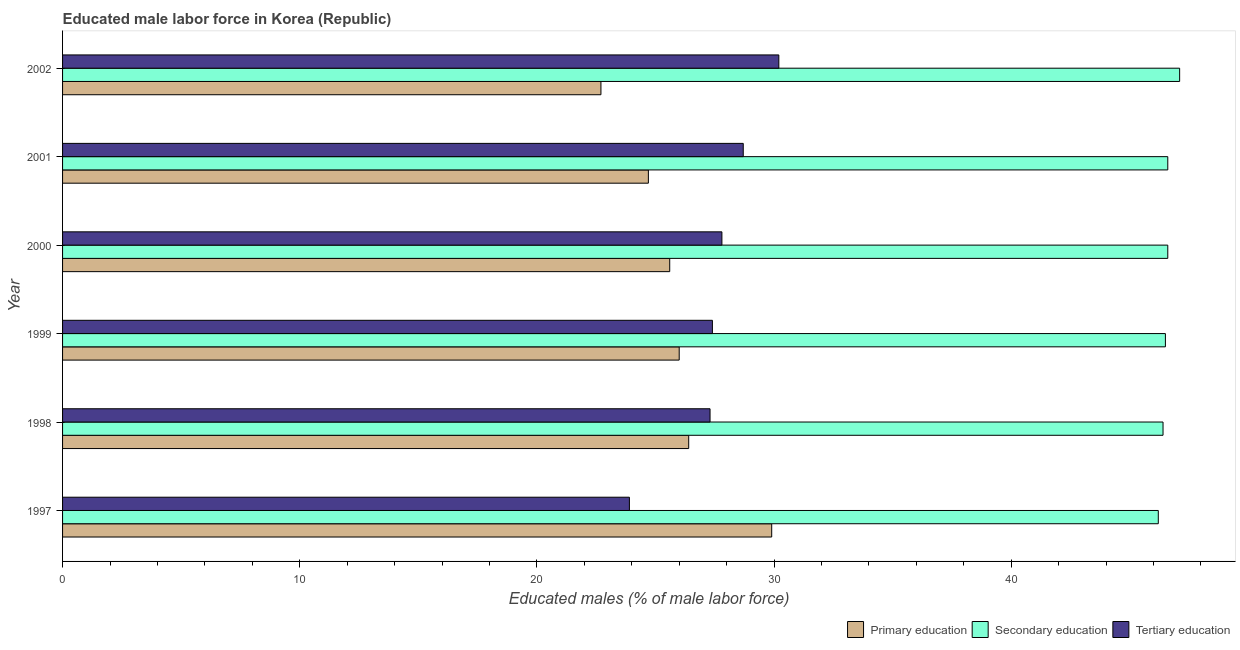How many different coloured bars are there?
Ensure brevity in your answer.  3. How many groups of bars are there?
Your response must be concise. 6. Are the number of bars on each tick of the Y-axis equal?
Give a very brief answer. Yes. In how many cases, is the number of bars for a given year not equal to the number of legend labels?
Provide a succinct answer. 0. What is the percentage of male labor force who received primary education in 2001?
Keep it short and to the point. 24.7. Across all years, what is the maximum percentage of male labor force who received secondary education?
Make the answer very short. 47.1. Across all years, what is the minimum percentage of male labor force who received primary education?
Your answer should be compact. 22.7. What is the total percentage of male labor force who received secondary education in the graph?
Your answer should be very brief. 279.4. What is the difference between the percentage of male labor force who received primary education in 2002 and the percentage of male labor force who received secondary education in 1999?
Your answer should be very brief. -23.8. What is the average percentage of male labor force who received secondary education per year?
Your response must be concise. 46.57. In how many years, is the percentage of male labor force who received tertiary education greater than 10 %?
Ensure brevity in your answer.  6. What is the ratio of the percentage of male labor force who received primary education in 1998 to that in 2002?
Give a very brief answer. 1.16. Is the percentage of male labor force who received tertiary education in 1999 less than that in 2000?
Make the answer very short. Yes. Is the difference between the percentage of male labor force who received tertiary education in 1997 and 2002 greater than the difference between the percentage of male labor force who received primary education in 1997 and 2002?
Provide a succinct answer. No. In how many years, is the percentage of male labor force who received tertiary education greater than the average percentage of male labor force who received tertiary education taken over all years?
Make the answer very short. 3. Is the sum of the percentage of male labor force who received tertiary education in 1998 and 1999 greater than the maximum percentage of male labor force who received secondary education across all years?
Give a very brief answer. Yes. What does the 1st bar from the top in 1998 represents?
Offer a very short reply. Tertiary education. What does the 2nd bar from the bottom in 1998 represents?
Your answer should be compact. Secondary education. Is it the case that in every year, the sum of the percentage of male labor force who received primary education and percentage of male labor force who received secondary education is greater than the percentage of male labor force who received tertiary education?
Offer a very short reply. Yes. How many years are there in the graph?
Offer a very short reply. 6. What is the difference between two consecutive major ticks on the X-axis?
Provide a short and direct response. 10. Does the graph contain any zero values?
Your answer should be compact. No. How many legend labels are there?
Offer a terse response. 3. How are the legend labels stacked?
Your answer should be very brief. Horizontal. What is the title of the graph?
Keep it short and to the point. Educated male labor force in Korea (Republic). Does "Interest" appear as one of the legend labels in the graph?
Offer a terse response. No. What is the label or title of the X-axis?
Offer a terse response. Educated males (% of male labor force). What is the label or title of the Y-axis?
Your response must be concise. Year. What is the Educated males (% of male labor force) of Primary education in 1997?
Offer a very short reply. 29.9. What is the Educated males (% of male labor force) of Secondary education in 1997?
Ensure brevity in your answer.  46.2. What is the Educated males (% of male labor force) in Tertiary education in 1997?
Your response must be concise. 23.9. What is the Educated males (% of male labor force) in Primary education in 1998?
Offer a very short reply. 26.4. What is the Educated males (% of male labor force) of Secondary education in 1998?
Make the answer very short. 46.4. What is the Educated males (% of male labor force) in Tertiary education in 1998?
Offer a terse response. 27.3. What is the Educated males (% of male labor force) in Primary education in 1999?
Provide a succinct answer. 26. What is the Educated males (% of male labor force) in Secondary education in 1999?
Provide a succinct answer. 46.5. What is the Educated males (% of male labor force) of Tertiary education in 1999?
Your answer should be very brief. 27.4. What is the Educated males (% of male labor force) in Primary education in 2000?
Your answer should be very brief. 25.6. What is the Educated males (% of male labor force) of Secondary education in 2000?
Make the answer very short. 46.6. What is the Educated males (% of male labor force) of Tertiary education in 2000?
Provide a succinct answer. 27.8. What is the Educated males (% of male labor force) in Primary education in 2001?
Offer a terse response. 24.7. What is the Educated males (% of male labor force) in Secondary education in 2001?
Give a very brief answer. 46.6. What is the Educated males (% of male labor force) in Tertiary education in 2001?
Give a very brief answer. 28.7. What is the Educated males (% of male labor force) of Primary education in 2002?
Ensure brevity in your answer.  22.7. What is the Educated males (% of male labor force) in Secondary education in 2002?
Offer a terse response. 47.1. What is the Educated males (% of male labor force) in Tertiary education in 2002?
Provide a short and direct response. 30.2. Across all years, what is the maximum Educated males (% of male labor force) of Primary education?
Ensure brevity in your answer.  29.9. Across all years, what is the maximum Educated males (% of male labor force) in Secondary education?
Your response must be concise. 47.1. Across all years, what is the maximum Educated males (% of male labor force) of Tertiary education?
Ensure brevity in your answer.  30.2. Across all years, what is the minimum Educated males (% of male labor force) in Primary education?
Your answer should be very brief. 22.7. Across all years, what is the minimum Educated males (% of male labor force) of Secondary education?
Offer a very short reply. 46.2. Across all years, what is the minimum Educated males (% of male labor force) in Tertiary education?
Offer a terse response. 23.9. What is the total Educated males (% of male labor force) in Primary education in the graph?
Provide a short and direct response. 155.3. What is the total Educated males (% of male labor force) of Secondary education in the graph?
Your response must be concise. 279.4. What is the total Educated males (% of male labor force) of Tertiary education in the graph?
Provide a succinct answer. 165.3. What is the difference between the Educated males (% of male labor force) in Tertiary education in 1997 and that in 1998?
Keep it short and to the point. -3.4. What is the difference between the Educated males (% of male labor force) of Primary education in 1997 and that in 1999?
Keep it short and to the point. 3.9. What is the difference between the Educated males (% of male labor force) of Tertiary education in 1997 and that in 1999?
Provide a succinct answer. -3.5. What is the difference between the Educated males (% of male labor force) in Tertiary education in 1997 and that in 2000?
Make the answer very short. -3.9. What is the difference between the Educated males (% of male labor force) of Primary education in 1997 and that in 2001?
Ensure brevity in your answer.  5.2. What is the difference between the Educated males (% of male labor force) in Tertiary education in 1997 and that in 2001?
Your response must be concise. -4.8. What is the difference between the Educated males (% of male labor force) in Secondary education in 1997 and that in 2002?
Provide a succinct answer. -0.9. What is the difference between the Educated males (% of male labor force) in Tertiary education in 1998 and that in 1999?
Give a very brief answer. -0.1. What is the difference between the Educated males (% of male labor force) of Secondary education in 1998 and that in 2000?
Ensure brevity in your answer.  -0.2. What is the difference between the Educated males (% of male labor force) in Secondary education in 1998 and that in 2001?
Keep it short and to the point. -0.2. What is the difference between the Educated males (% of male labor force) of Primary education in 1998 and that in 2002?
Give a very brief answer. 3.7. What is the difference between the Educated males (% of male labor force) in Secondary education in 1998 and that in 2002?
Provide a succinct answer. -0.7. What is the difference between the Educated males (% of male labor force) in Secondary education in 1999 and that in 2000?
Give a very brief answer. -0.1. What is the difference between the Educated males (% of male labor force) of Tertiary education in 1999 and that in 2000?
Keep it short and to the point. -0.4. What is the difference between the Educated males (% of male labor force) in Primary education in 1999 and that in 2001?
Provide a succinct answer. 1.3. What is the difference between the Educated males (% of male labor force) in Secondary education in 1999 and that in 2001?
Make the answer very short. -0.1. What is the difference between the Educated males (% of male labor force) in Secondary education in 1999 and that in 2002?
Keep it short and to the point. -0.6. What is the difference between the Educated males (% of male labor force) in Tertiary education in 1999 and that in 2002?
Provide a short and direct response. -2.8. What is the difference between the Educated males (% of male labor force) of Primary education in 2000 and that in 2001?
Offer a very short reply. 0.9. What is the difference between the Educated males (% of male labor force) of Secondary education in 2000 and that in 2001?
Make the answer very short. 0. What is the difference between the Educated males (% of male labor force) in Tertiary education in 2000 and that in 2001?
Provide a short and direct response. -0.9. What is the difference between the Educated males (% of male labor force) of Primary education in 2000 and that in 2002?
Your answer should be very brief. 2.9. What is the difference between the Educated males (% of male labor force) of Primary education in 2001 and that in 2002?
Offer a terse response. 2. What is the difference between the Educated males (% of male labor force) of Secondary education in 2001 and that in 2002?
Offer a terse response. -0.5. What is the difference between the Educated males (% of male labor force) in Tertiary education in 2001 and that in 2002?
Make the answer very short. -1.5. What is the difference between the Educated males (% of male labor force) of Primary education in 1997 and the Educated males (% of male labor force) of Secondary education in 1998?
Keep it short and to the point. -16.5. What is the difference between the Educated males (% of male labor force) in Primary education in 1997 and the Educated males (% of male labor force) in Tertiary education in 1998?
Ensure brevity in your answer.  2.6. What is the difference between the Educated males (% of male labor force) in Primary education in 1997 and the Educated males (% of male labor force) in Secondary education in 1999?
Your response must be concise. -16.6. What is the difference between the Educated males (% of male labor force) in Primary education in 1997 and the Educated males (% of male labor force) in Tertiary education in 1999?
Your answer should be very brief. 2.5. What is the difference between the Educated males (% of male labor force) in Secondary education in 1997 and the Educated males (% of male labor force) in Tertiary education in 1999?
Provide a succinct answer. 18.8. What is the difference between the Educated males (% of male labor force) of Primary education in 1997 and the Educated males (% of male labor force) of Secondary education in 2000?
Provide a short and direct response. -16.7. What is the difference between the Educated males (% of male labor force) of Primary education in 1997 and the Educated males (% of male labor force) of Tertiary education in 2000?
Ensure brevity in your answer.  2.1. What is the difference between the Educated males (% of male labor force) in Primary education in 1997 and the Educated males (% of male labor force) in Secondary education in 2001?
Provide a short and direct response. -16.7. What is the difference between the Educated males (% of male labor force) in Primary education in 1997 and the Educated males (% of male labor force) in Tertiary education in 2001?
Keep it short and to the point. 1.2. What is the difference between the Educated males (% of male labor force) in Primary education in 1997 and the Educated males (% of male labor force) in Secondary education in 2002?
Ensure brevity in your answer.  -17.2. What is the difference between the Educated males (% of male labor force) in Primary education in 1997 and the Educated males (% of male labor force) in Tertiary education in 2002?
Ensure brevity in your answer.  -0.3. What is the difference between the Educated males (% of male labor force) of Primary education in 1998 and the Educated males (% of male labor force) of Secondary education in 1999?
Your response must be concise. -20.1. What is the difference between the Educated males (% of male labor force) in Primary education in 1998 and the Educated males (% of male labor force) in Secondary education in 2000?
Your response must be concise. -20.2. What is the difference between the Educated males (% of male labor force) of Secondary education in 1998 and the Educated males (% of male labor force) of Tertiary education in 2000?
Provide a short and direct response. 18.6. What is the difference between the Educated males (% of male labor force) of Primary education in 1998 and the Educated males (% of male labor force) of Secondary education in 2001?
Keep it short and to the point. -20.2. What is the difference between the Educated males (% of male labor force) of Primary education in 1998 and the Educated males (% of male labor force) of Tertiary education in 2001?
Keep it short and to the point. -2.3. What is the difference between the Educated males (% of male labor force) in Primary education in 1998 and the Educated males (% of male labor force) in Secondary education in 2002?
Give a very brief answer. -20.7. What is the difference between the Educated males (% of male labor force) of Primary education in 1998 and the Educated males (% of male labor force) of Tertiary education in 2002?
Provide a succinct answer. -3.8. What is the difference between the Educated males (% of male labor force) in Secondary education in 1998 and the Educated males (% of male labor force) in Tertiary education in 2002?
Offer a very short reply. 16.2. What is the difference between the Educated males (% of male labor force) of Primary education in 1999 and the Educated males (% of male labor force) of Secondary education in 2000?
Ensure brevity in your answer.  -20.6. What is the difference between the Educated males (% of male labor force) in Primary education in 1999 and the Educated males (% of male labor force) in Tertiary education in 2000?
Make the answer very short. -1.8. What is the difference between the Educated males (% of male labor force) of Primary education in 1999 and the Educated males (% of male labor force) of Secondary education in 2001?
Keep it short and to the point. -20.6. What is the difference between the Educated males (% of male labor force) in Secondary education in 1999 and the Educated males (% of male labor force) in Tertiary education in 2001?
Make the answer very short. 17.8. What is the difference between the Educated males (% of male labor force) in Primary education in 1999 and the Educated males (% of male labor force) in Secondary education in 2002?
Your answer should be compact. -21.1. What is the difference between the Educated males (% of male labor force) of Primary education in 1999 and the Educated males (% of male labor force) of Tertiary education in 2002?
Offer a terse response. -4.2. What is the difference between the Educated males (% of male labor force) in Secondary education in 1999 and the Educated males (% of male labor force) in Tertiary education in 2002?
Ensure brevity in your answer.  16.3. What is the difference between the Educated males (% of male labor force) in Primary education in 2000 and the Educated males (% of male labor force) in Secondary education in 2001?
Ensure brevity in your answer.  -21. What is the difference between the Educated males (% of male labor force) of Primary education in 2000 and the Educated males (% of male labor force) of Tertiary education in 2001?
Offer a very short reply. -3.1. What is the difference between the Educated males (% of male labor force) in Primary education in 2000 and the Educated males (% of male labor force) in Secondary education in 2002?
Your answer should be compact. -21.5. What is the difference between the Educated males (% of male labor force) in Primary education in 2000 and the Educated males (% of male labor force) in Tertiary education in 2002?
Offer a very short reply. -4.6. What is the difference between the Educated males (% of male labor force) in Primary education in 2001 and the Educated males (% of male labor force) in Secondary education in 2002?
Give a very brief answer. -22.4. What is the difference between the Educated males (% of male labor force) of Primary education in 2001 and the Educated males (% of male labor force) of Tertiary education in 2002?
Provide a short and direct response. -5.5. What is the difference between the Educated males (% of male labor force) of Secondary education in 2001 and the Educated males (% of male labor force) of Tertiary education in 2002?
Offer a terse response. 16.4. What is the average Educated males (% of male labor force) in Primary education per year?
Ensure brevity in your answer.  25.88. What is the average Educated males (% of male labor force) in Secondary education per year?
Provide a short and direct response. 46.57. What is the average Educated males (% of male labor force) of Tertiary education per year?
Your answer should be compact. 27.55. In the year 1997, what is the difference between the Educated males (% of male labor force) of Primary education and Educated males (% of male labor force) of Secondary education?
Give a very brief answer. -16.3. In the year 1997, what is the difference between the Educated males (% of male labor force) of Primary education and Educated males (% of male labor force) of Tertiary education?
Offer a very short reply. 6. In the year 1997, what is the difference between the Educated males (% of male labor force) in Secondary education and Educated males (% of male labor force) in Tertiary education?
Make the answer very short. 22.3. In the year 1998, what is the difference between the Educated males (% of male labor force) in Primary education and Educated males (% of male labor force) in Secondary education?
Provide a short and direct response. -20. In the year 1998, what is the difference between the Educated males (% of male labor force) of Secondary education and Educated males (% of male labor force) of Tertiary education?
Ensure brevity in your answer.  19.1. In the year 1999, what is the difference between the Educated males (% of male labor force) of Primary education and Educated males (% of male labor force) of Secondary education?
Provide a succinct answer. -20.5. In the year 2000, what is the difference between the Educated males (% of male labor force) in Secondary education and Educated males (% of male labor force) in Tertiary education?
Offer a terse response. 18.8. In the year 2001, what is the difference between the Educated males (% of male labor force) in Primary education and Educated males (% of male labor force) in Secondary education?
Your answer should be compact. -21.9. In the year 2001, what is the difference between the Educated males (% of male labor force) of Secondary education and Educated males (% of male labor force) of Tertiary education?
Give a very brief answer. 17.9. In the year 2002, what is the difference between the Educated males (% of male labor force) in Primary education and Educated males (% of male labor force) in Secondary education?
Make the answer very short. -24.4. In the year 2002, what is the difference between the Educated males (% of male labor force) of Primary education and Educated males (% of male labor force) of Tertiary education?
Provide a short and direct response. -7.5. What is the ratio of the Educated males (% of male labor force) of Primary education in 1997 to that in 1998?
Make the answer very short. 1.13. What is the ratio of the Educated males (% of male labor force) in Tertiary education in 1997 to that in 1998?
Give a very brief answer. 0.88. What is the ratio of the Educated males (% of male labor force) in Primary education in 1997 to that in 1999?
Give a very brief answer. 1.15. What is the ratio of the Educated males (% of male labor force) in Secondary education in 1997 to that in 1999?
Keep it short and to the point. 0.99. What is the ratio of the Educated males (% of male labor force) in Tertiary education in 1997 to that in 1999?
Provide a short and direct response. 0.87. What is the ratio of the Educated males (% of male labor force) in Primary education in 1997 to that in 2000?
Ensure brevity in your answer.  1.17. What is the ratio of the Educated males (% of male labor force) of Secondary education in 1997 to that in 2000?
Offer a very short reply. 0.99. What is the ratio of the Educated males (% of male labor force) of Tertiary education in 1997 to that in 2000?
Provide a short and direct response. 0.86. What is the ratio of the Educated males (% of male labor force) of Primary education in 1997 to that in 2001?
Offer a very short reply. 1.21. What is the ratio of the Educated males (% of male labor force) in Tertiary education in 1997 to that in 2001?
Your answer should be very brief. 0.83. What is the ratio of the Educated males (% of male labor force) in Primary education in 1997 to that in 2002?
Ensure brevity in your answer.  1.32. What is the ratio of the Educated males (% of male labor force) of Secondary education in 1997 to that in 2002?
Ensure brevity in your answer.  0.98. What is the ratio of the Educated males (% of male labor force) in Tertiary education in 1997 to that in 2002?
Offer a very short reply. 0.79. What is the ratio of the Educated males (% of male labor force) of Primary education in 1998 to that in 1999?
Keep it short and to the point. 1.02. What is the ratio of the Educated males (% of male labor force) of Secondary education in 1998 to that in 1999?
Ensure brevity in your answer.  1. What is the ratio of the Educated males (% of male labor force) of Primary education in 1998 to that in 2000?
Give a very brief answer. 1.03. What is the ratio of the Educated males (% of male labor force) in Primary education in 1998 to that in 2001?
Your answer should be very brief. 1.07. What is the ratio of the Educated males (% of male labor force) in Tertiary education in 1998 to that in 2001?
Keep it short and to the point. 0.95. What is the ratio of the Educated males (% of male labor force) of Primary education in 1998 to that in 2002?
Your answer should be very brief. 1.16. What is the ratio of the Educated males (% of male labor force) in Secondary education in 1998 to that in 2002?
Offer a very short reply. 0.99. What is the ratio of the Educated males (% of male labor force) of Tertiary education in 1998 to that in 2002?
Your answer should be compact. 0.9. What is the ratio of the Educated males (% of male labor force) of Primary education in 1999 to that in 2000?
Your answer should be very brief. 1.02. What is the ratio of the Educated males (% of male labor force) in Secondary education in 1999 to that in 2000?
Offer a very short reply. 1. What is the ratio of the Educated males (% of male labor force) in Tertiary education in 1999 to that in 2000?
Make the answer very short. 0.99. What is the ratio of the Educated males (% of male labor force) of Primary education in 1999 to that in 2001?
Your answer should be compact. 1.05. What is the ratio of the Educated males (% of male labor force) of Tertiary education in 1999 to that in 2001?
Your answer should be compact. 0.95. What is the ratio of the Educated males (% of male labor force) of Primary education in 1999 to that in 2002?
Give a very brief answer. 1.15. What is the ratio of the Educated males (% of male labor force) in Secondary education in 1999 to that in 2002?
Offer a very short reply. 0.99. What is the ratio of the Educated males (% of male labor force) of Tertiary education in 1999 to that in 2002?
Your answer should be compact. 0.91. What is the ratio of the Educated males (% of male labor force) in Primary education in 2000 to that in 2001?
Ensure brevity in your answer.  1.04. What is the ratio of the Educated males (% of male labor force) in Secondary education in 2000 to that in 2001?
Provide a succinct answer. 1. What is the ratio of the Educated males (% of male labor force) of Tertiary education in 2000 to that in 2001?
Your answer should be very brief. 0.97. What is the ratio of the Educated males (% of male labor force) in Primary education in 2000 to that in 2002?
Your response must be concise. 1.13. What is the ratio of the Educated males (% of male labor force) in Secondary education in 2000 to that in 2002?
Provide a succinct answer. 0.99. What is the ratio of the Educated males (% of male labor force) in Tertiary education in 2000 to that in 2002?
Provide a succinct answer. 0.92. What is the ratio of the Educated males (% of male labor force) in Primary education in 2001 to that in 2002?
Keep it short and to the point. 1.09. What is the ratio of the Educated males (% of male labor force) of Secondary education in 2001 to that in 2002?
Your response must be concise. 0.99. What is the ratio of the Educated males (% of male labor force) of Tertiary education in 2001 to that in 2002?
Give a very brief answer. 0.95. What is the difference between the highest and the lowest Educated males (% of male labor force) of Tertiary education?
Offer a very short reply. 6.3. 